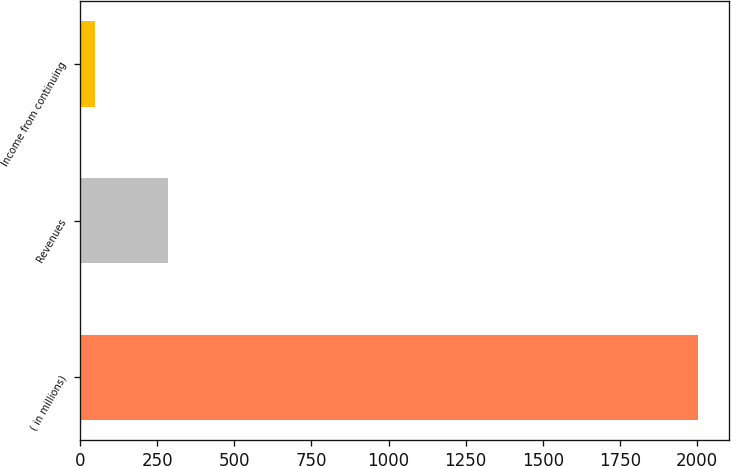<chart> <loc_0><loc_0><loc_500><loc_500><bar_chart><fcel>( in millions)<fcel>Revenues<fcel>Income from continuing<nl><fcel>2004<fcel>285<fcel>47<nl></chart> 